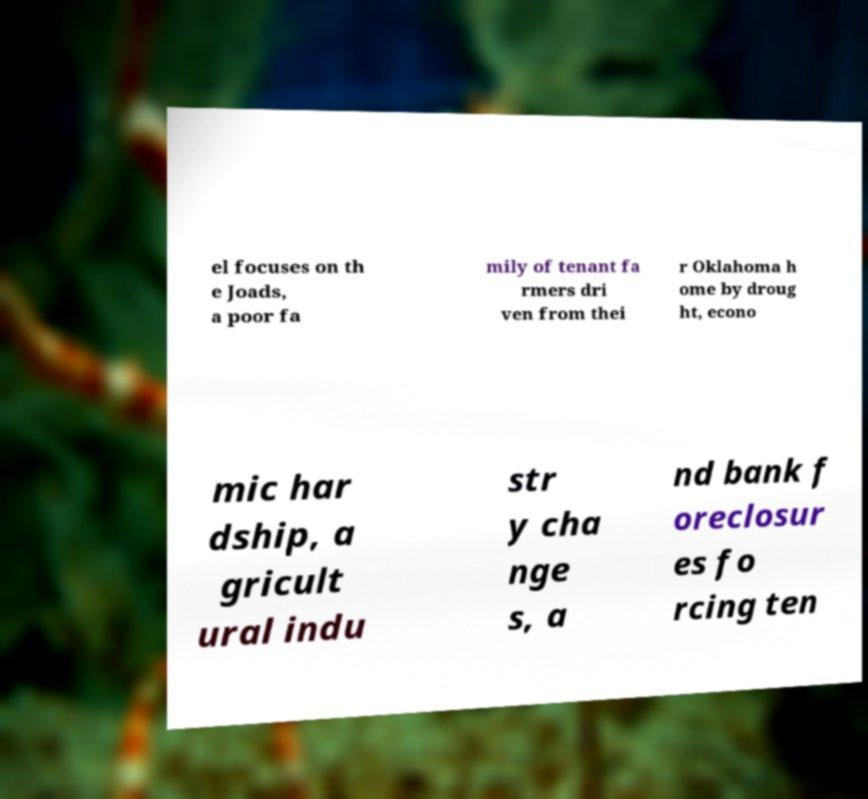There's text embedded in this image that I need extracted. Can you transcribe it verbatim? el focuses on th e Joads, a poor fa mily of tenant fa rmers dri ven from thei r Oklahoma h ome by droug ht, econo mic har dship, a gricult ural indu str y cha nge s, a nd bank f oreclosur es fo rcing ten 